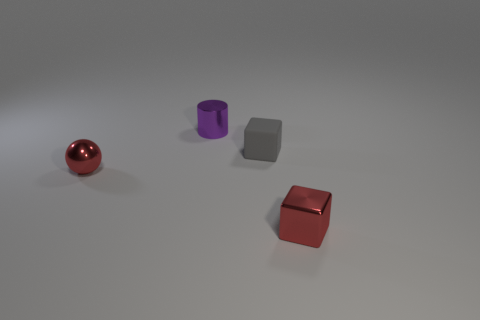Does the image indicate what time of the day it might be? The image appears to have been taken in a controlled lighting environment, such as a photo studio or a rendering simulation, making it difficult to determine the time of day. 